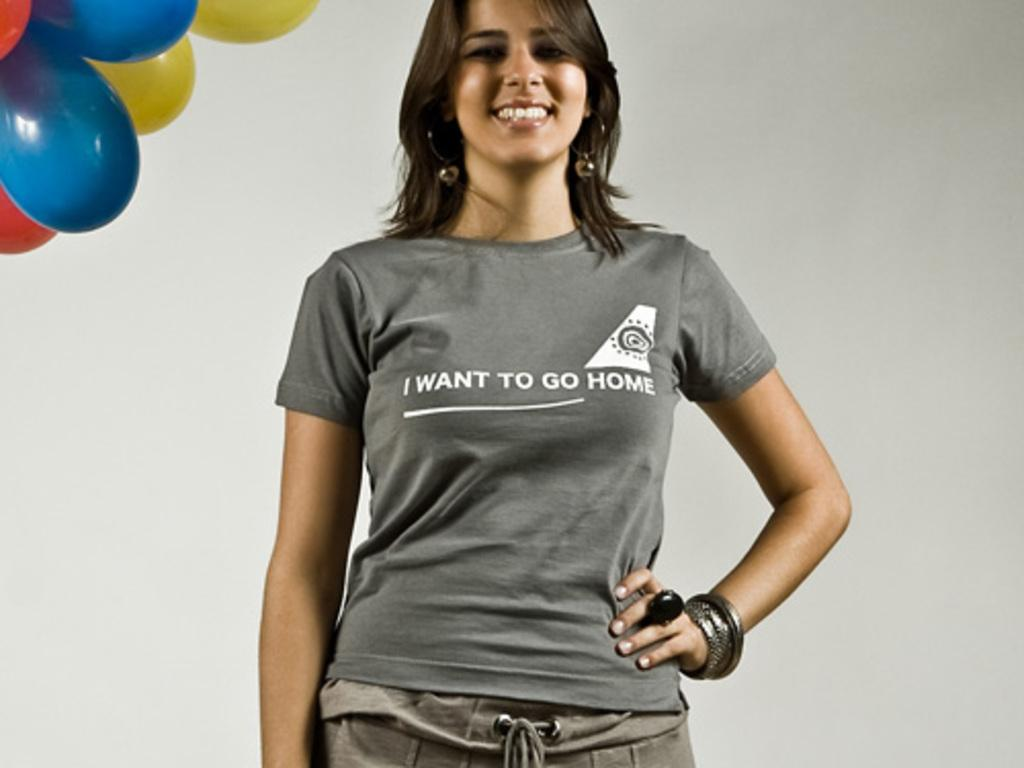Where was the image taken? The image is taken indoors. Who is the main subject in the image? There is a woman in the center of the image. What is the woman wearing? The woman is wearing a t-shirt. What expression does the woman have? The woman is smiling. What is the woman standing on? The woman is standing on the ground. What can be seen in the background of the image? There are balloons and a wall visible in the background of the image. Is there a river flowing through the room in the image? No, there is no river visible in the image. The image is taken indoors, and the only visible background elements are balloons and a wall. 